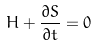<formula> <loc_0><loc_0><loc_500><loc_500>H + \frac { \partial S } { \partial t } = 0</formula> 